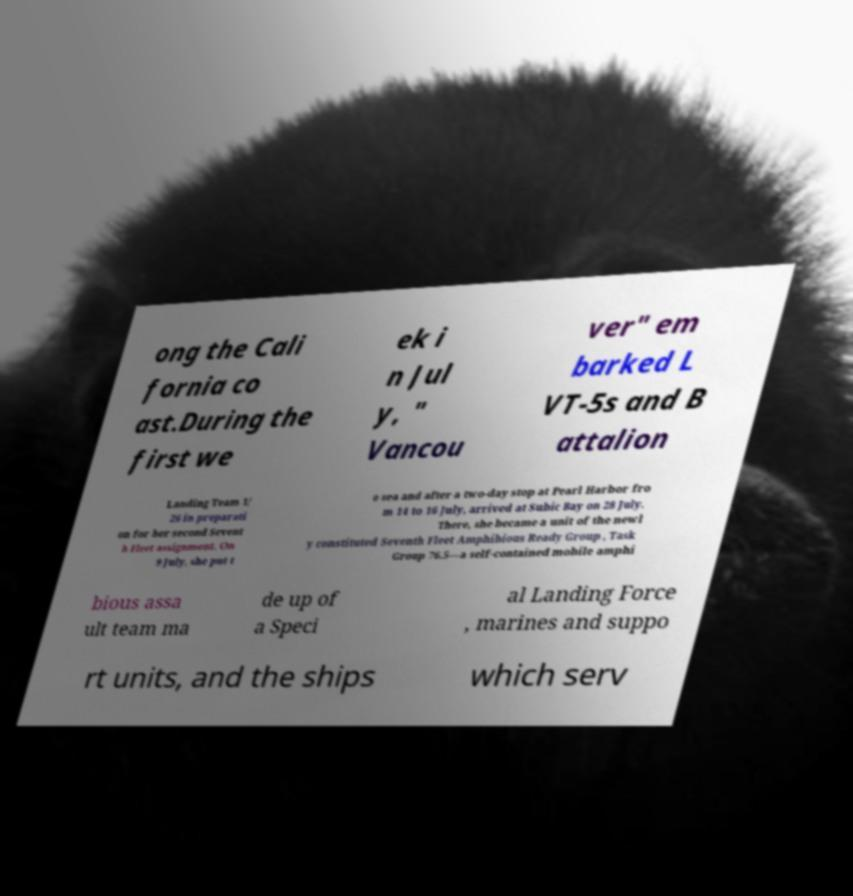For documentation purposes, I need the text within this image transcribed. Could you provide that? ong the Cali fornia co ast.During the first we ek i n Jul y, " Vancou ver" em barked L VT-5s and B attalion Landing Team 1/ 26 in preparati on for her second Sevent h Fleet assignment. On 9 July, she put t o sea and after a two-day stop at Pearl Harbor fro m 14 to 16 July, arrived at Subic Bay on 28 July. There, she became a unit of the newl y constituted Seventh Fleet Amphibious Ready Group , Task Group 76.5—a self-contained mobile amphi bious assa ult team ma de up of a Speci al Landing Force , marines and suppo rt units, and the ships which serv 